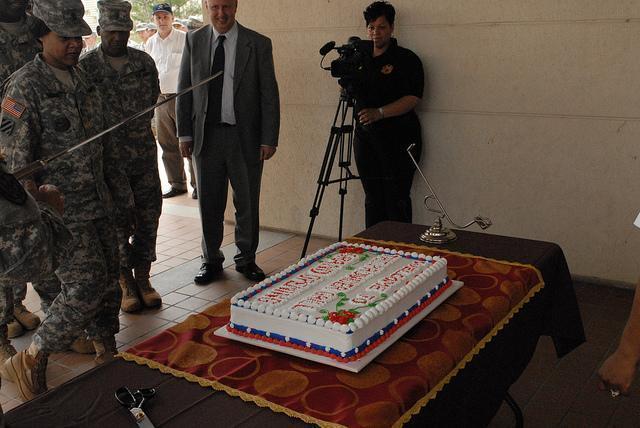What message does this cake send to those that see it?
Answer the question by selecting the correct answer among the 4 following choices.
Options: Happy birthday, welcome, happy holiday, none. Welcome. 